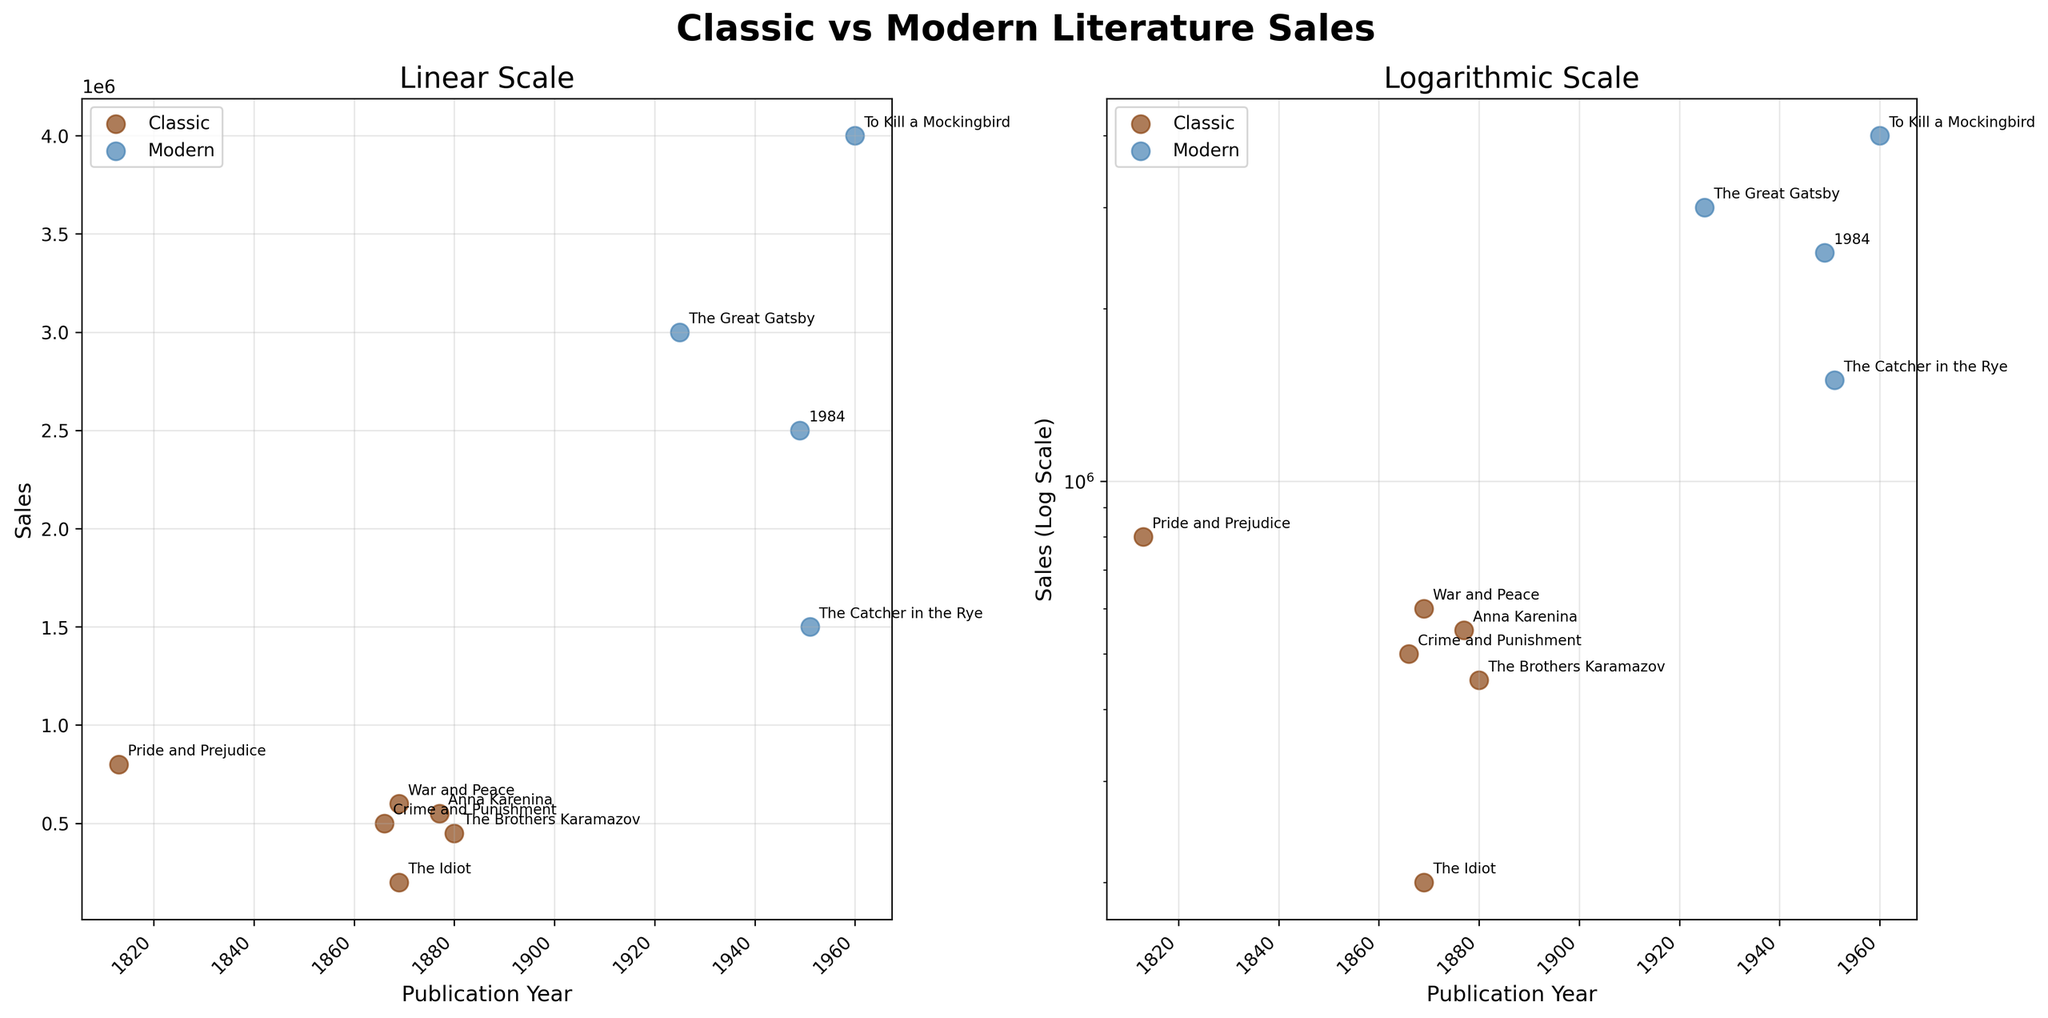What's the title of the figure? The title is displayed at the top center of the figure.
Answer: Classic vs Modern Literature Sales What does the right subplot indicate about sales? The right subplot uses a logarithmic scale for sales, providing a clearer understanding of variations over large ranges.
Answer: Sales in Logarithmic Scale Which genre has a book with the latest publication year and what is the year? Check the latest point on the x-axis for each genre. For Modern, it's 1960; for Classic, it's 1880.
Answer: Modern, 1960 Which book has the highest sales in the dataset? Identify the highest point on the y-axis in either subplot. Both indicate the same highest sales.
Answer: To Kill a Mockingbird On the logarithmic scale, how do the sales of 'The Great Gatsby' compare to 'War and Peace'? Locate both books on the right subplot and compare their y-values. 'The Great Gatsby' has higher sales.
Answer: 'The Great Gatsby' has higher sales What year did the highest-selling Classic book get published? Identify the highest point for the Classic genre on either subplot.
Answer: 1813 How do the sales trends of Classic and Modern literature compare visually? Classic literature has sales data mostly below 1,000,000, while Modern literature generally has much higher sales.
Answer: Modern literature has higher sales Why is the right subplot necessary when we have the left subplot? The logarithmic scale helps to compare data points that have a wide range in sales values, simplifying visual interpretation.
Answer: To better compare a wide range of sales values Which book was published earliest and what is its sales? Locate the earliest point on the x-axis in either subplot. It's 'Pride and Prejudice' with 800,000 sales.
Answer: Pride and Prejudice, 800,000 What sales trend can you infer about literature over time from the figure? Observing the x-axis and y-axis, recent publications (mostly Modern) have significantly higher sales compared to older (Classic) ones.
Answer: More recent publications tend to have higher sales 